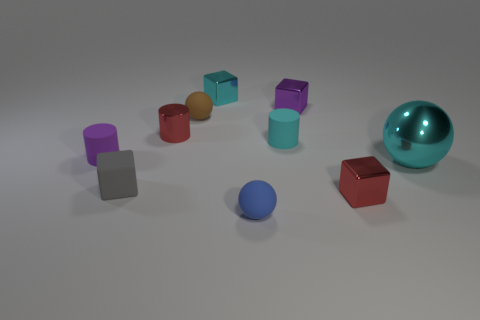Subtract all blocks. How many objects are left? 6 Add 5 purple objects. How many purple objects are left? 7 Add 4 red cylinders. How many red cylinders exist? 5 Subtract 0 brown cylinders. How many objects are left? 10 Subtract all large metal objects. Subtract all small brown rubber things. How many objects are left? 8 